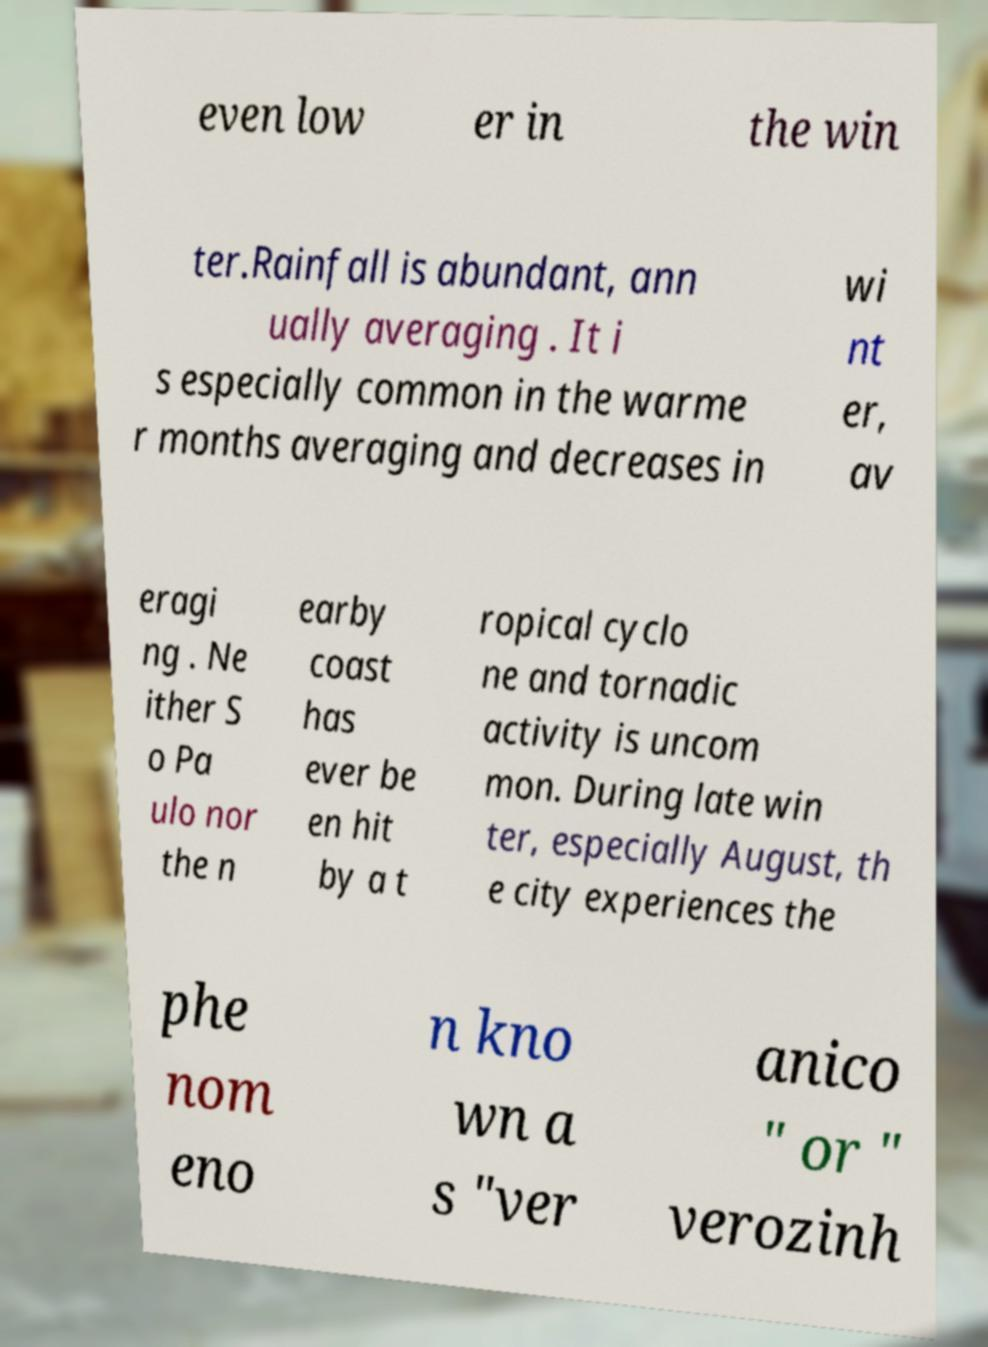I need the written content from this picture converted into text. Can you do that? even low er in the win ter.Rainfall is abundant, ann ually averaging . It i s especially common in the warme r months averaging and decreases in wi nt er, av eragi ng . Ne ither S o Pa ulo nor the n earby coast has ever be en hit by a t ropical cyclo ne and tornadic activity is uncom mon. During late win ter, especially August, th e city experiences the phe nom eno n kno wn a s "ver anico " or " verozinh 